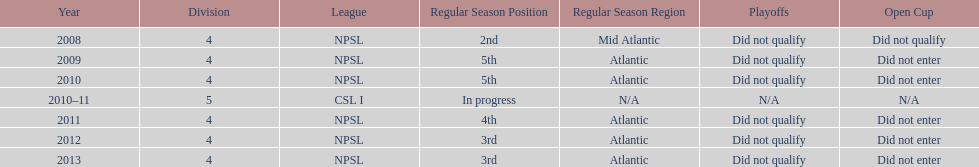How many years did they not qualify for the playoffs? 6. 